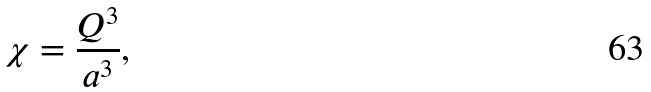Convert formula to latex. <formula><loc_0><loc_0><loc_500><loc_500>\chi = \frac { Q ^ { 3 } } { a ^ { 3 } } ,</formula> 